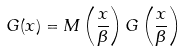Convert formula to latex. <formula><loc_0><loc_0><loc_500><loc_500>G ( x ) = M \left ( \frac { x } { \beta } \right ) G \left ( \frac { x } { \beta } \right )</formula> 